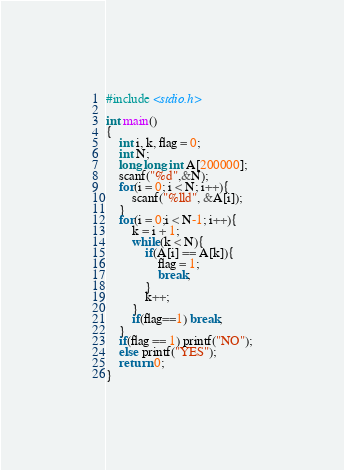Convert code to text. <code><loc_0><loc_0><loc_500><loc_500><_C_>#include <stdio.h>

int main()
{
	int i, k, flag = 0;
	int N;
	long long int A[200000];
	scanf("%d",&N);
	for(i = 0; i < N; i++){
		scanf("%lld", &A[i]);
	}
	for(i = 0;i < N-1; i++){
		k = i + 1;
		while(k < N){
			if(A[i] == A[k]){
				flag = 1;
				break;
			}
			k++;
		}
		if(flag==1) break;
	}
	if(flag == 1) printf("NO");
	else printf("YES");
    return 0;
}</code> 